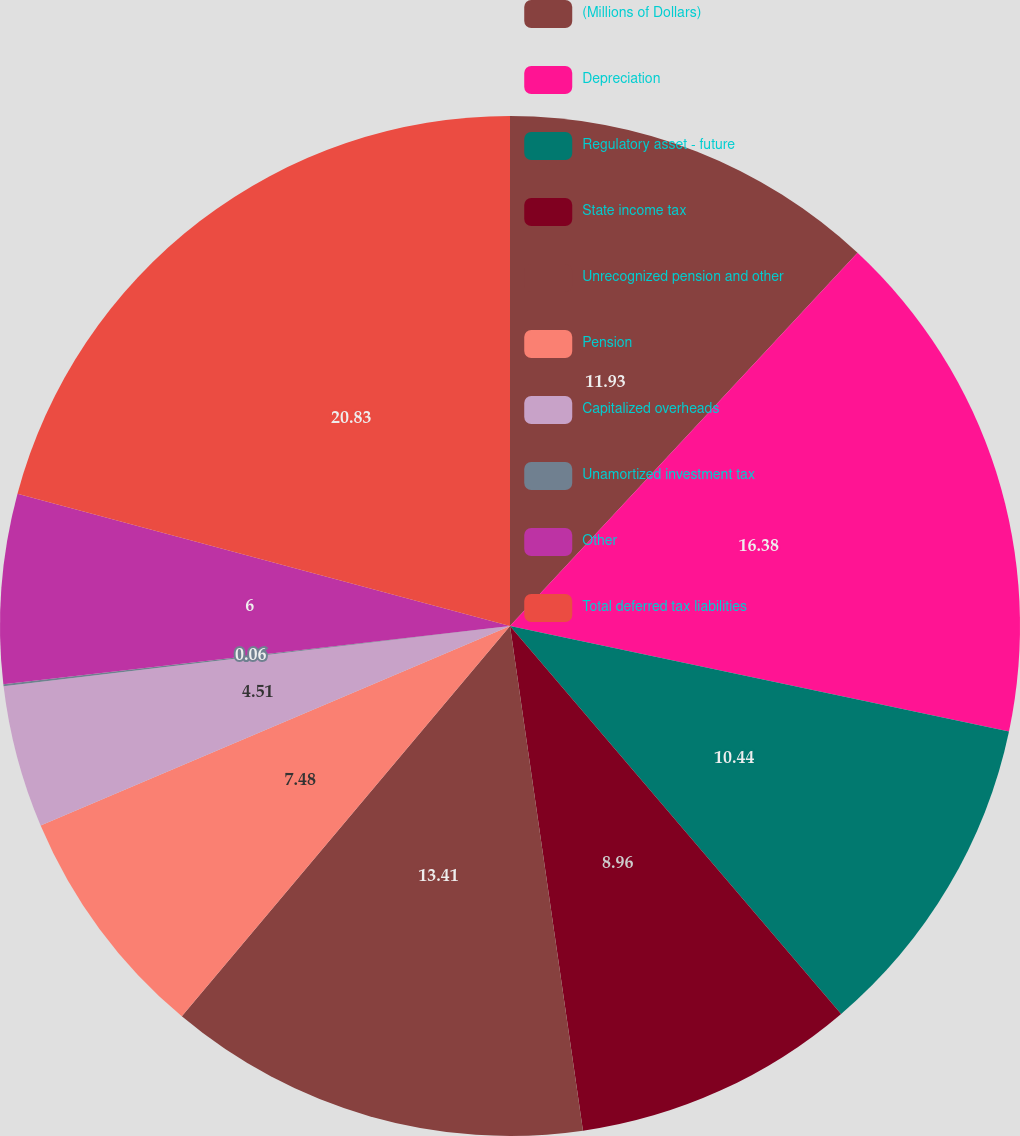<chart> <loc_0><loc_0><loc_500><loc_500><pie_chart><fcel>(Millions of Dollars)<fcel>Depreciation<fcel>Regulatory asset - future<fcel>State income tax<fcel>Unrecognized pension and other<fcel>Pension<fcel>Capitalized overheads<fcel>Unamortized investment tax<fcel>Other<fcel>Total deferred tax liabilities<nl><fcel>11.93%<fcel>16.38%<fcel>10.44%<fcel>8.96%<fcel>13.41%<fcel>7.48%<fcel>4.51%<fcel>0.06%<fcel>6.0%<fcel>20.82%<nl></chart> 